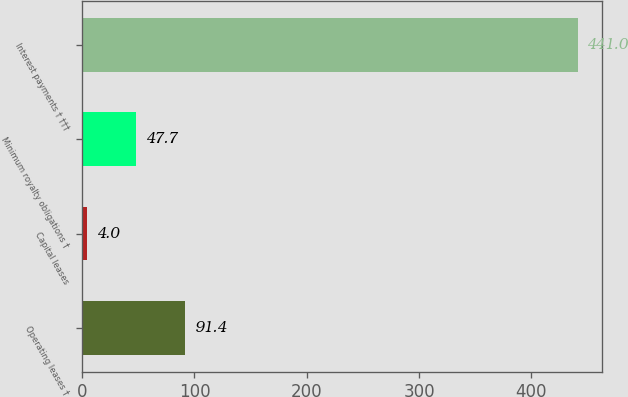<chart> <loc_0><loc_0><loc_500><loc_500><bar_chart><fcel>Operating leases †<fcel>Capital leases<fcel>Minimum royalty obligations †<fcel>Interest payments † †††<nl><fcel>91.4<fcel>4<fcel>47.7<fcel>441<nl></chart> 